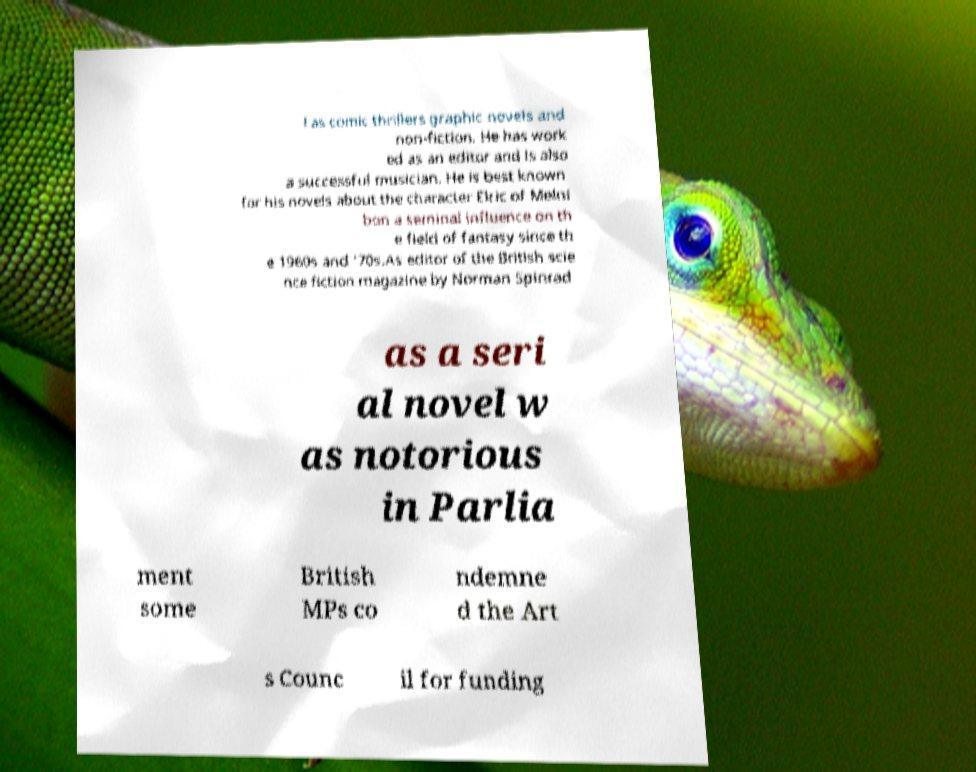Could you assist in decoding the text presented in this image and type it out clearly? l as comic thrillers graphic novels and non-fiction. He has work ed as an editor and is also a successful musician. He is best known for his novels about the character Elric of Melni bon a seminal influence on th e field of fantasy since th e 1960s and '70s.As editor of the British scie nce fiction magazine by Norman Spinrad as a seri al novel w as notorious in Parlia ment some British MPs co ndemne d the Art s Counc il for funding 